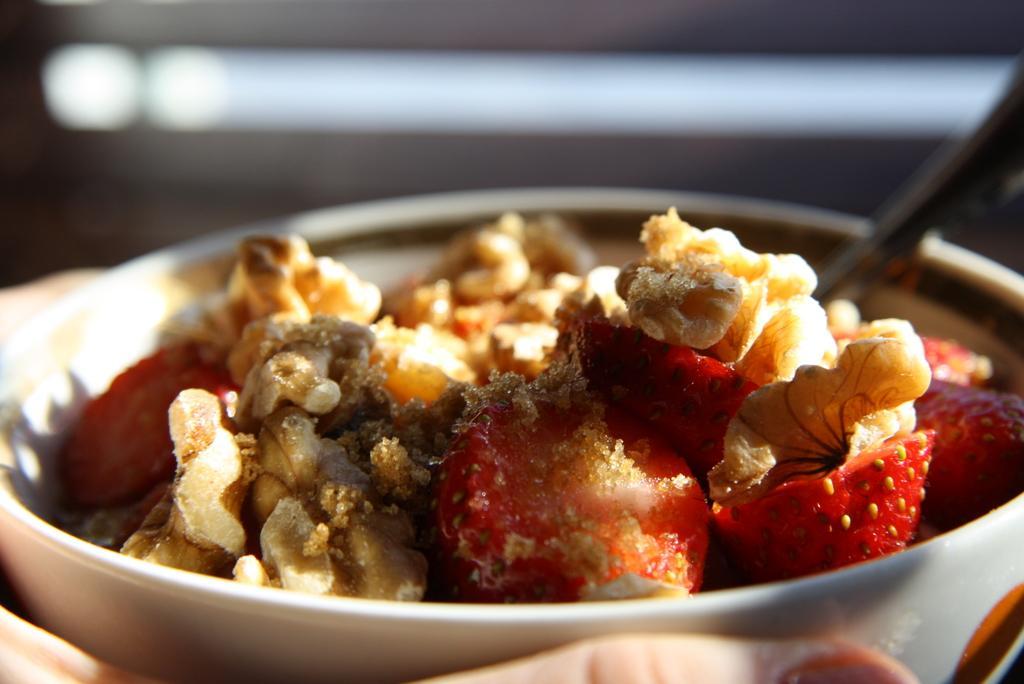Please provide a concise description of this image. In this picture there is some food in the white bowl. Behind there is a blur background. 